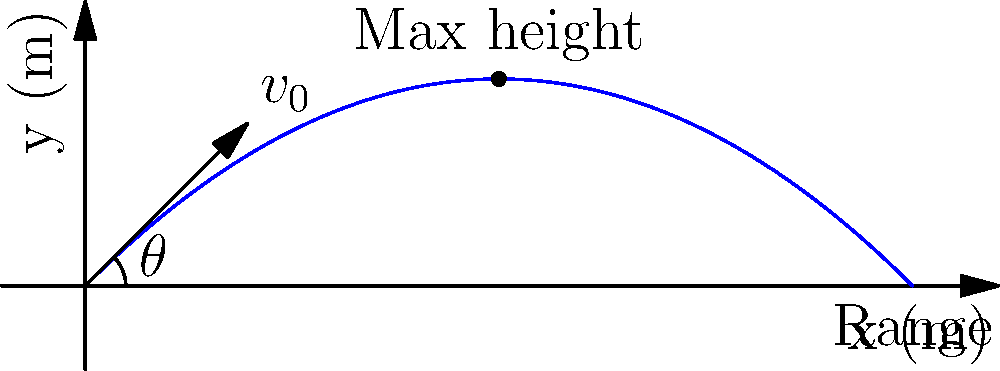As part of a project to optimize irrigation coverage in rural areas, you're analyzing the trajectory of water droplets from a sprinkler system. If a water droplet is ejected from a sprinkler at an initial velocity of 10 m/s at an angle of 45° above the horizontal, what is the maximum height reached by the droplet? Assume air resistance is negligible and use g = 9.8 m/s². To find the maximum height reached by the water droplet, we can follow these steps:

1) The vertical component of the initial velocity is given by:
   $v_{0y} = v_0 \sin(\theta) = 10 \cdot \sin(45°) = 10 \cdot \frac{\sqrt{2}}{2} \approx 7.07$ m/s

2) The time to reach the maximum height is when the vertical velocity becomes zero:
   $v_y = v_{0y} - gt = 0$
   $t = \frac{v_{0y}}{g} = \frac{7.07}{9.8} \approx 0.72$ seconds

3) The maximum height can be calculated using the equation:
   $y = v_{0y}t - \frac{1}{2}gt^2$

4) Substituting the values:
   $y_{max} = 7.07 \cdot 0.72 - \frac{1}{2} \cdot 9.8 \cdot 0.72^2$
   $y_{max} = 5.09 - 2.54 = 2.55$ meters

5) We can also use the energy conservation equation to verify:
   $y_{max} = \frac{v_{0y}^2}{2g} = \frac{7.07^2}{2 \cdot 9.8} \approx 2.55$ meters

Therefore, the maximum height reached by the water droplet is approximately 2.55 meters.
Answer: 2.55 meters 